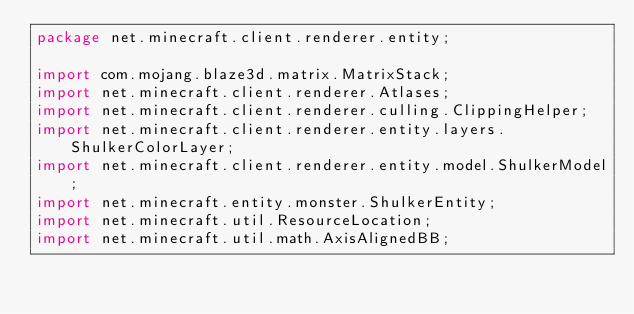Convert code to text. <code><loc_0><loc_0><loc_500><loc_500><_Java_>package net.minecraft.client.renderer.entity;

import com.mojang.blaze3d.matrix.MatrixStack;
import net.minecraft.client.renderer.Atlases;
import net.minecraft.client.renderer.culling.ClippingHelper;
import net.minecraft.client.renderer.entity.layers.ShulkerColorLayer;
import net.minecraft.client.renderer.entity.model.ShulkerModel;
import net.minecraft.entity.monster.ShulkerEntity;
import net.minecraft.util.ResourceLocation;
import net.minecraft.util.math.AxisAlignedBB;</code> 